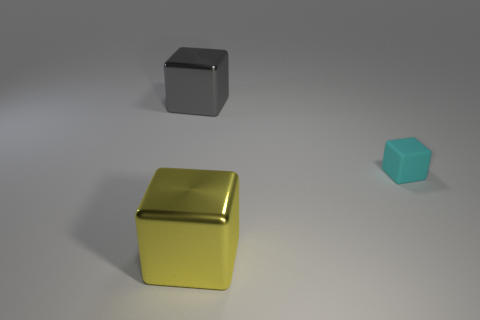Add 2 big green matte cylinders. How many objects exist? 5 Subtract all gray shiny blocks. How many blocks are left? 2 Subtract 0 green cylinders. How many objects are left? 3 Subtract all brown blocks. Subtract all green spheres. How many blocks are left? 3 Subtract all yellow metal cubes. Subtract all large purple things. How many objects are left? 2 Add 2 small cyan matte cubes. How many small cyan matte cubes are left? 3 Add 1 gray shiny spheres. How many gray shiny spheres exist? 1 